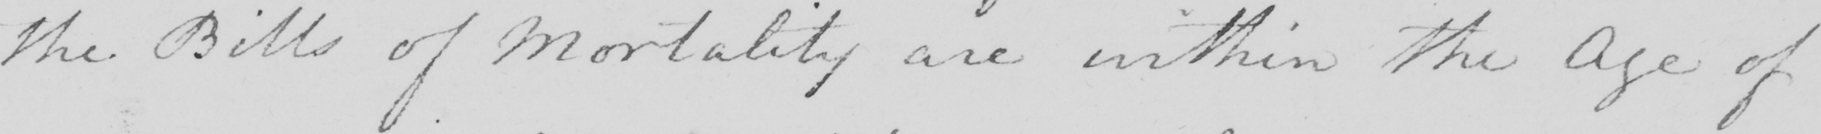Transcribe the text shown in this historical manuscript line. the Bills of Mortality are within the Age of 